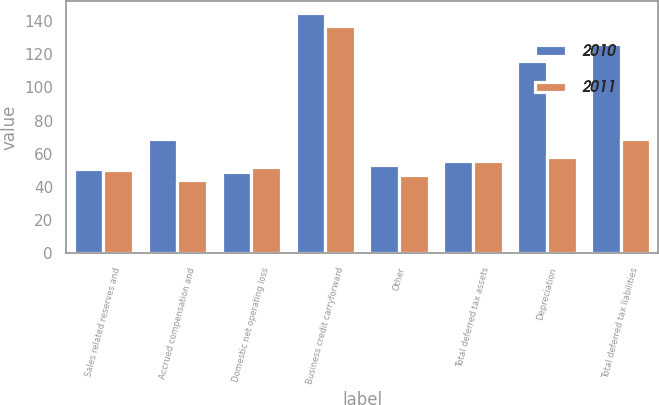Convert chart. <chart><loc_0><loc_0><loc_500><loc_500><stacked_bar_chart><ecel><fcel>Sales related reserves and<fcel>Accrued compensation and<fcel>Domestic net operating loss<fcel>Business credit carryforward<fcel>Other<fcel>Total deferred tax assets<fcel>Depreciation<fcel>Total deferred tax liabilities<nl><fcel>2010<fcel>51<fcel>69<fcel>49<fcel>145<fcel>53<fcel>55.5<fcel>116<fcel>126<nl><fcel>2011<fcel>50<fcel>44<fcel>52<fcel>137<fcel>47<fcel>55.5<fcel>58<fcel>69<nl></chart> 